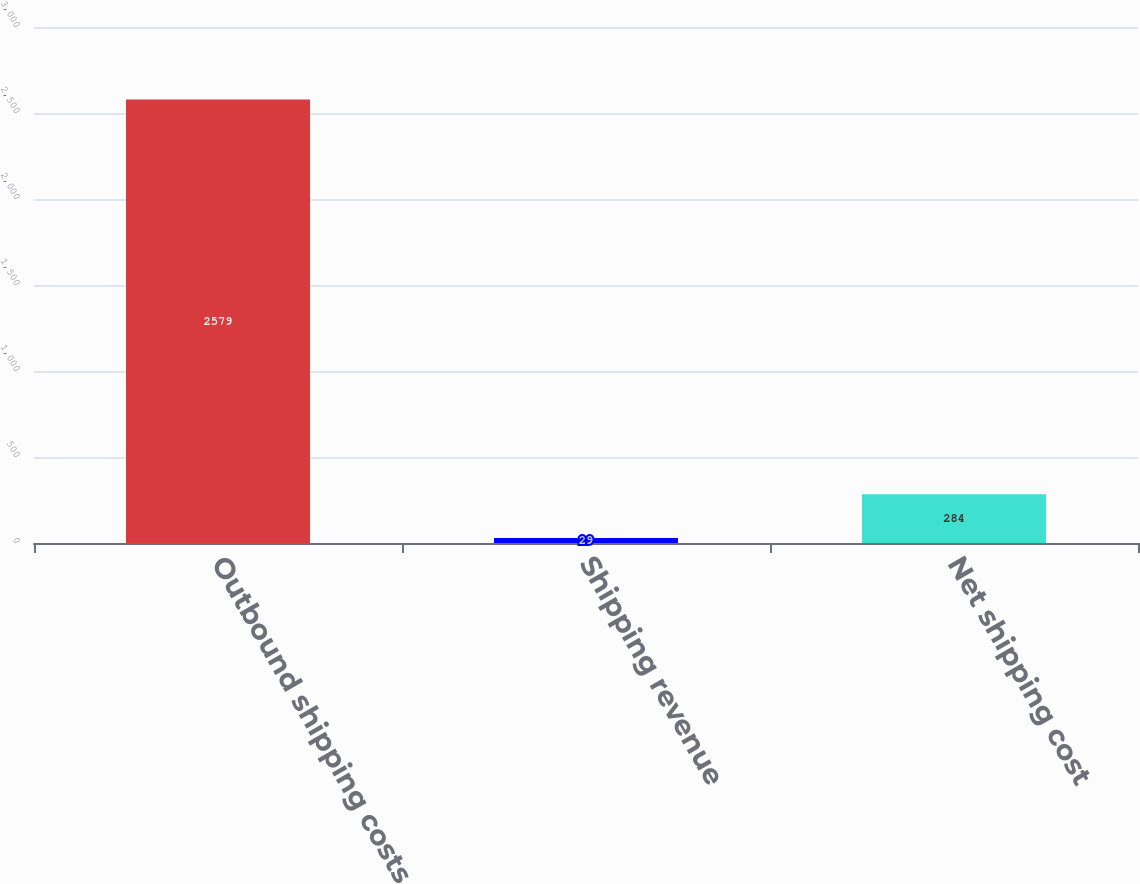Convert chart. <chart><loc_0><loc_0><loc_500><loc_500><bar_chart><fcel>Outbound shipping costs<fcel>Shipping revenue<fcel>Net shipping cost<nl><fcel>2579<fcel>29<fcel>284<nl></chart> 